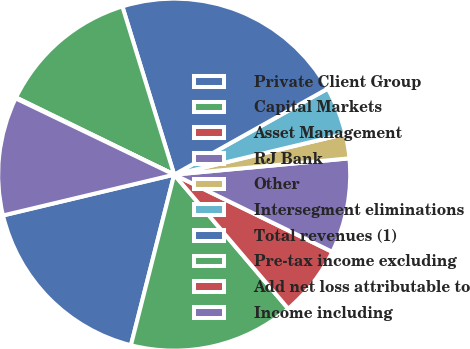Convert chart to OTSL. <chart><loc_0><loc_0><loc_500><loc_500><pie_chart><fcel>Private Client Group<fcel>Capital Markets<fcel>Asset Management<fcel>RJ Bank<fcel>Other<fcel>Intersegment eliminations<fcel>Total revenues (1)<fcel>Pre-tax income excluding<fcel>Add net loss attributable to<fcel>Income including<nl><fcel>17.32%<fcel>15.17%<fcel>6.55%<fcel>8.71%<fcel>2.25%<fcel>4.4%<fcel>21.63%<fcel>13.02%<fcel>0.09%<fcel>10.86%<nl></chart> 